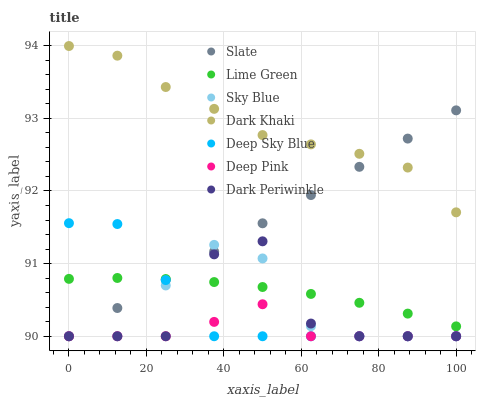Does Deep Pink have the minimum area under the curve?
Answer yes or no. Yes. Does Dark Khaki have the maximum area under the curve?
Answer yes or no. Yes. Does Slate have the minimum area under the curve?
Answer yes or no. No. Does Slate have the maximum area under the curve?
Answer yes or no. No. Is Slate the smoothest?
Answer yes or no. Yes. Is Dark Periwinkle the roughest?
Answer yes or no. Yes. Is Dark Khaki the smoothest?
Answer yes or no. No. Is Dark Khaki the roughest?
Answer yes or no. No. Does Deep Pink have the lowest value?
Answer yes or no. Yes. Does Dark Khaki have the lowest value?
Answer yes or no. No. Does Dark Khaki have the highest value?
Answer yes or no. Yes. Does Slate have the highest value?
Answer yes or no. No. Is Deep Pink less than Dark Khaki?
Answer yes or no. Yes. Is Dark Khaki greater than Lime Green?
Answer yes or no. Yes. Does Dark Periwinkle intersect Lime Green?
Answer yes or no. Yes. Is Dark Periwinkle less than Lime Green?
Answer yes or no. No. Is Dark Periwinkle greater than Lime Green?
Answer yes or no. No. Does Deep Pink intersect Dark Khaki?
Answer yes or no. No. 